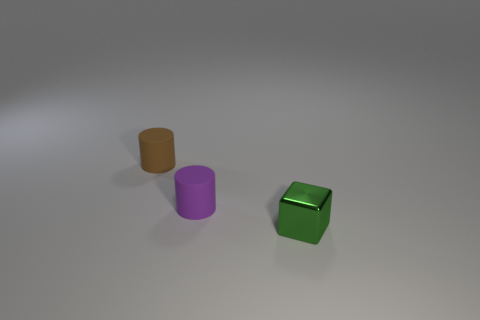Add 3 green blocks. How many objects exist? 6 Subtract all gray cylinders. Subtract all cyan spheres. How many cylinders are left? 2 Subtract all green blocks. How many brown cylinders are left? 1 Subtract all cylinders. Subtract all yellow balls. How many objects are left? 1 Add 3 cubes. How many cubes are left? 4 Add 2 purple metal spheres. How many purple metal spheres exist? 2 Subtract 1 green cubes. How many objects are left? 2 Subtract all cylinders. How many objects are left? 1 